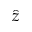Convert formula to latex. <formula><loc_0><loc_0><loc_500><loc_500>\hat { z }</formula> 